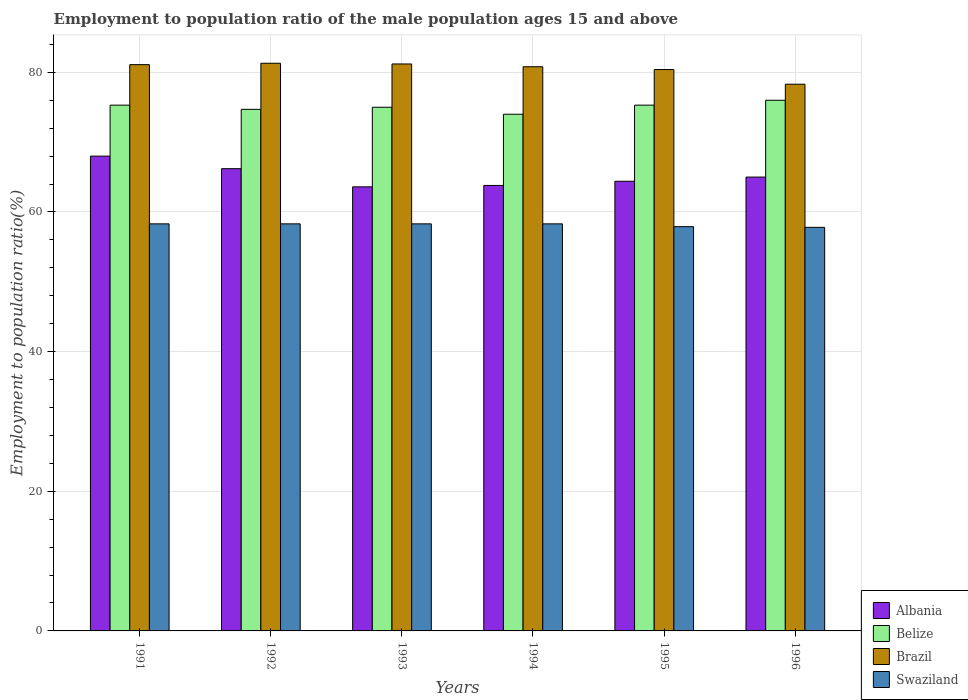How many different coloured bars are there?
Your answer should be very brief. 4. Are the number of bars on each tick of the X-axis equal?
Provide a short and direct response. Yes. How many bars are there on the 5th tick from the right?
Your answer should be very brief. 4. In how many cases, is the number of bars for a given year not equal to the number of legend labels?
Make the answer very short. 0. What is the employment to population ratio in Belize in 1991?
Offer a terse response. 75.3. Across all years, what is the minimum employment to population ratio in Albania?
Provide a short and direct response. 63.6. What is the total employment to population ratio in Swaziland in the graph?
Your answer should be very brief. 348.9. What is the difference between the employment to population ratio in Brazil in 1991 and that in 1993?
Make the answer very short. -0.1. What is the difference between the employment to population ratio in Belize in 1992 and the employment to population ratio in Brazil in 1994?
Your response must be concise. -6.1. What is the average employment to population ratio in Belize per year?
Make the answer very short. 75.05. In the year 1991, what is the difference between the employment to population ratio in Swaziland and employment to population ratio in Albania?
Provide a succinct answer. -9.7. In how many years, is the employment to population ratio in Swaziland greater than 36 %?
Ensure brevity in your answer.  6. What is the ratio of the employment to population ratio in Belize in 1991 to that in 1996?
Give a very brief answer. 0.99. Is the difference between the employment to population ratio in Swaziland in 1991 and 1992 greater than the difference between the employment to population ratio in Albania in 1991 and 1992?
Your answer should be very brief. No. What is the difference between the highest and the second highest employment to population ratio in Swaziland?
Your answer should be compact. 0. What is the difference between the highest and the lowest employment to population ratio in Belize?
Give a very brief answer. 2. Is the sum of the employment to population ratio in Belize in 1991 and 1993 greater than the maximum employment to population ratio in Albania across all years?
Your answer should be compact. Yes. Is it the case that in every year, the sum of the employment to population ratio in Brazil and employment to population ratio in Swaziland is greater than the sum of employment to population ratio in Albania and employment to population ratio in Belize?
Keep it short and to the point. Yes. What does the 1st bar from the left in 1993 represents?
Keep it short and to the point. Albania. What does the 3rd bar from the right in 1992 represents?
Give a very brief answer. Belize. Is it the case that in every year, the sum of the employment to population ratio in Brazil and employment to population ratio in Albania is greater than the employment to population ratio in Belize?
Provide a succinct answer. Yes. Are all the bars in the graph horizontal?
Offer a very short reply. No. How many years are there in the graph?
Make the answer very short. 6. Are the values on the major ticks of Y-axis written in scientific E-notation?
Provide a short and direct response. No. How are the legend labels stacked?
Your answer should be very brief. Vertical. What is the title of the graph?
Offer a terse response. Employment to population ratio of the male population ages 15 and above. Does "Latin America(all income levels)" appear as one of the legend labels in the graph?
Offer a very short reply. No. What is the label or title of the X-axis?
Your answer should be compact. Years. What is the label or title of the Y-axis?
Your response must be concise. Employment to population ratio(%). What is the Employment to population ratio(%) of Albania in 1991?
Offer a very short reply. 68. What is the Employment to population ratio(%) in Belize in 1991?
Your response must be concise. 75.3. What is the Employment to population ratio(%) of Brazil in 1991?
Your response must be concise. 81.1. What is the Employment to population ratio(%) of Swaziland in 1991?
Provide a short and direct response. 58.3. What is the Employment to population ratio(%) of Albania in 1992?
Offer a very short reply. 66.2. What is the Employment to population ratio(%) in Belize in 1992?
Give a very brief answer. 74.7. What is the Employment to population ratio(%) of Brazil in 1992?
Ensure brevity in your answer.  81.3. What is the Employment to population ratio(%) in Swaziland in 1992?
Make the answer very short. 58.3. What is the Employment to population ratio(%) in Albania in 1993?
Your answer should be very brief. 63.6. What is the Employment to population ratio(%) of Belize in 1993?
Provide a short and direct response. 75. What is the Employment to population ratio(%) in Brazil in 1993?
Offer a very short reply. 81.2. What is the Employment to population ratio(%) of Swaziland in 1993?
Your answer should be compact. 58.3. What is the Employment to population ratio(%) in Albania in 1994?
Keep it short and to the point. 63.8. What is the Employment to population ratio(%) of Belize in 1994?
Make the answer very short. 74. What is the Employment to population ratio(%) of Brazil in 1994?
Your answer should be compact. 80.8. What is the Employment to population ratio(%) in Swaziland in 1994?
Your answer should be very brief. 58.3. What is the Employment to population ratio(%) of Albania in 1995?
Your answer should be very brief. 64.4. What is the Employment to population ratio(%) of Belize in 1995?
Keep it short and to the point. 75.3. What is the Employment to population ratio(%) in Brazil in 1995?
Offer a terse response. 80.4. What is the Employment to population ratio(%) of Swaziland in 1995?
Provide a succinct answer. 57.9. What is the Employment to population ratio(%) in Albania in 1996?
Your response must be concise. 65. What is the Employment to population ratio(%) of Brazil in 1996?
Your response must be concise. 78.3. What is the Employment to population ratio(%) of Swaziland in 1996?
Provide a succinct answer. 57.8. Across all years, what is the maximum Employment to population ratio(%) in Brazil?
Your answer should be very brief. 81.3. Across all years, what is the maximum Employment to population ratio(%) of Swaziland?
Offer a terse response. 58.3. Across all years, what is the minimum Employment to population ratio(%) of Albania?
Provide a short and direct response. 63.6. Across all years, what is the minimum Employment to population ratio(%) of Belize?
Ensure brevity in your answer.  74. Across all years, what is the minimum Employment to population ratio(%) of Brazil?
Provide a succinct answer. 78.3. Across all years, what is the minimum Employment to population ratio(%) in Swaziland?
Give a very brief answer. 57.8. What is the total Employment to population ratio(%) of Albania in the graph?
Give a very brief answer. 391. What is the total Employment to population ratio(%) in Belize in the graph?
Your response must be concise. 450.3. What is the total Employment to population ratio(%) in Brazil in the graph?
Offer a terse response. 483.1. What is the total Employment to population ratio(%) of Swaziland in the graph?
Provide a succinct answer. 348.9. What is the difference between the Employment to population ratio(%) in Brazil in 1991 and that in 1992?
Provide a succinct answer. -0.2. What is the difference between the Employment to population ratio(%) of Belize in 1991 and that in 1993?
Ensure brevity in your answer.  0.3. What is the difference between the Employment to population ratio(%) of Albania in 1991 and that in 1994?
Your answer should be compact. 4.2. What is the difference between the Employment to population ratio(%) of Swaziland in 1991 and that in 1994?
Your response must be concise. 0. What is the difference between the Employment to population ratio(%) in Albania in 1991 and that in 1995?
Provide a succinct answer. 3.6. What is the difference between the Employment to population ratio(%) in Belize in 1991 and that in 1996?
Give a very brief answer. -0.7. What is the difference between the Employment to population ratio(%) in Albania in 1992 and that in 1993?
Offer a terse response. 2.6. What is the difference between the Employment to population ratio(%) of Belize in 1992 and that in 1993?
Offer a terse response. -0.3. What is the difference between the Employment to population ratio(%) of Swaziland in 1992 and that in 1993?
Keep it short and to the point. 0. What is the difference between the Employment to population ratio(%) in Belize in 1992 and that in 1994?
Provide a succinct answer. 0.7. What is the difference between the Employment to population ratio(%) of Brazil in 1992 and that in 1995?
Provide a succinct answer. 0.9. What is the difference between the Employment to population ratio(%) in Brazil in 1992 and that in 1996?
Your answer should be compact. 3. What is the difference between the Employment to population ratio(%) of Albania in 1993 and that in 1994?
Provide a short and direct response. -0.2. What is the difference between the Employment to population ratio(%) of Belize in 1993 and that in 1994?
Keep it short and to the point. 1. What is the difference between the Employment to population ratio(%) of Brazil in 1993 and that in 1994?
Provide a succinct answer. 0.4. What is the difference between the Employment to population ratio(%) of Swaziland in 1993 and that in 1994?
Provide a succinct answer. 0. What is the difference between the Employment to population ratio(%) of Albania in 1993 and that in 1995?
Provide a short and direct response. -0.8. What is the difference between the Employment to population ratio(%) in Albania in 1993 and that in 1996?
Your response must be concise. -1.4. What is the difference between the Employment to population ratio(%) in Belize in 1993 and that in 1996?
Your answer should be very brief. -1. What is the difference between the Employment to population ratio(%) in Albania in 1994 and that in 1995?
Your response must be concise. -0.6. What is the difference between the Employment to population ratio(%) in Brazil in 1994 and that in 1995?
Your answer should be compact. 0.4. What is the difference between the Employment to population ratio(%) of Brazil in 1994 and that in 1996?
Offer a very short reply. 2.5. What is the difference between the Employment to population ratio(%) in Albania in 1995 and that in 1996?
Your answer should be compact. -0.6. What is the difference between the Employment to population ratio(%) in Brazil in 1995 and that in 1996?
Provide a short and direct response. 2.1. What is the difference between the Employment to population ratio(%) in Swaziland in 1995 and that in 1996?
Offer a terse response. 0.1. What is the difference between the Employment to population ratio(%) in Brazil in 1991 and the Employment to population ratio(%) in Swaziland in 1992?
Give a very brief answer. 22.8. What is the difference between the Employment to population ratio(%) in Albania in 1991 and the Employment to population ratio(%) in Belize in 1993?
Your answer should be compact. -7. What is the difference between the Employment to population ratio(%) in Belize in 1991 and the Employment to population ratio(%) in Swaziland in 1993?
Your answer should be very brief. 17. What is the difference between the Employment to population ratio(%) of Brazil in 1991 and the Employment to population ratio(%) of Swaziland in 1993?
Make the answer very short. 22.8. What is the difference between the Employment to population ratio(%) of Albania in 1991 and the Employment to population ratio(%) of Belize in 1994?
Your answer should be compact. -6. What is the difference between the Employment to population ratio(%) of Albania in 1991 and the Employment to population ratio(%) of Swaziland in 1994?
Make the answer very short. 9.7. What is the difference between the Employment to population ratio(%) in Brazil in 1991 and the Employment to population ratio(%) in Swaziland in 1994?
Give a very brief answer. 22.8. What is the difference between the Employment to population ratio(%) of Albania in 1991 and the Employment to population ratio(%) of Belize in 1995?
Offer a very short reply. -7.3. What is the difference between the Employment to population ratio(%) of Albania in 1991 and the Employment to population ratio(%) of Brazil in 1995?
Give a very brief answer. -12.4. What is the difference between the Employment to population ratio(%) in Albania in 1991 and the Employment to population ratio(%) in Swaziland in 1995?
Provide a succinct answer. 10.1. What is the difference between the Employment to population ratio(%) of Belize in 1991 and the Employment to population ratio(%) of Swaziland in 1995?
Make the answer very short. 17.4. What is the difference between the Employment to population ratio(%) of Brazil in 1991 and the Employment to population ratio(%) of Swaziland in 1995?
Give a very brief answer. 23.2. What is the difference between the Employment to population ratio(%) in Albania in 1991 and the Employment to population ratio(%) in Belize in 1996?
Provide a short and direct response. -8. What is the difference between the Employment to population ratio(%) in Albania in 1991 and the Employment to population ratio(%) in Swaziland in 1996?
Make the answer very short. 10.2. What is the difference between the Employment to population ratio(%) of Belize in 1991 and the Employment to population ratio(%) of Swaziland in 1996?
Provide a short and direct response. 17.5. What is the difference between the Employment to population ratio(%) of Brazil in 1991 and the Employment to population ratio(%) of Swaziland in 1996?
Your answer should be very brief. 23.3. What is the difference between the Employment to population ratio(%) in Albania in 1992 and the Employment to population ratio(%) in Belize in 1993?
Keep it short and to the point. -8.8. What is the difference between the Employment to population ratio(%) in Albania in 1992 and the Employment to population ratio(%) in Brazil in 1993?
Provide a succinct answer. -15. What is the difference between the Employment to population ratio(%) in Albania in 1992 and the Employment to population ratio(%) in Swaziland in 1993?
Keep it short and to the point. 7.9. What is the difference between the Employment to population ratio(%) in Belize in 1992 and the Employment to population ratio(%) in Brazil in 1993?
Offer a terse response. -6.5. What is the difference between the Employment to population ratio(%) of Albania in 1992 and the Employment to population ratio(%) of Brazil in 1994?
Ensure brevity in your answer.  -14.6. What is the difference between the Employment to population ratio(%) in Belize in 1992 and the Employment to population ratio(%) in Swaziland in 1994?
Your answer should be compact. 16.4. What is the difference between the Employment to population ratio(%) of Albania in 1992 and the Employment to population ratio(%) of Swaziland in 1995?
Give a very brief answer. 8.3. What is the difference between the Employment to population ratio(%) in Belize in 1992 and the Employment to population ratio(%) in Swaziland in 1995?
Make the answer very short. 16.8. What is the difference between the Employment to population ratio(%) in Brazil in 1992 and the Employment to population ratio(%) in Swaziland in 1995?
Provide a short and direct response. 23.4. What is the difference between the Employment to population ratio(%) in Albania in 1992 and the Employment to population ratio(%) in Belize in 1996?
Your response must be concise. -9.8. What is the difference between the Employment to population ratio(%) in Albania in 1992 and the Employment to population ratio(%) in Swaziland in 1996?
Offer a terse response. 8.4. What is the difference between the Employment to population ratio(%) in Albania in 1993 and the Employment to population ratio(%) in Belize in 1994?
Offer a very short reply. -10.4. What is the difference between the Employment to population ratio(%) in Albania in 1993 and the Employment to population ratio(%) in Brazil in 1994?
Offer a terse response. -17.2. What is the difference between the Employment to population ratio(%) in Belize in 1993 and the Employment to population ratio(%) in Brazil in 1994?
Provide a succinct answer. -5.8. What is the difference between the Employment to population ratio(%) of Brazil in 1993 and the Employment to population ratio(%) of Swaziland in 1994?
Keep it short and to the point. 22.9. What is the difference between the Employment to population ratio(%) in Albania in 1993 and the Employment to population ratio(%) in Belize in 1995?
Ensure brevity in your answer.  -11.7. What is the difference between the Employment to population ratio(%) in Albania in 1993 and the Employment to population ratio(%) in Brazil in 1995?
Give a very brief answer. -16.8. What is the difference between the Employment to population ratio(%) in Albania in 1993 and the Employment to population ratio(%) in Swaziland in 1995?
Your response must be concise. 5.7. What is the difference between the Employment to population ratio(%) of Brazil in 1993 and the Employment to population ratio(%) of Swaziland in 1995?
Offer a terse response. 23.3. What is the difference between the Employment to population ratio(%) of Albania in 1993 and the Employment to population ratio(%) of Belize in 1996?
Your answer should be very brief. -12.4. What is the difference between the Employment to population ratio(%) of Albania in 1993 and the Employment to population ratio(%) of Brazil in 1996?
Your answer should be compact. -14.7. What is the difference between the Employment to population ratio(%) in Albania in 1993 and the Employment to population ratio(%) in Swaziland in 1996?
Provide a short and direct response. 5.8. What is the difference between the Employment to population ratio(%) of Belize in 1993 and the Employment to population ratio(%) of Brazil in 1996?
Offer a terse response. -3.3. What is the difference between the Employment to population ratio(%) of Belize in 1993 and the Employment to population ratio(%) of Swaziland in 1996?
Keep it short and to the point. 17.2. What is the difference between the Employment to population ratio(%) in Brazil in 1993 and the Employment to population ratio(%) in Swaziland in 1996?
Give a very brief answer. 23.4. What is the difference between the Employment to population ratio(%) in Albania in 1994 and the Employment to population ratio(%) in Belize in 1995?
Offer a terse response. -11.5. What is the difference between the Employment to population ratio(%) in Albania in 1994 and the Employment to population ratio(%) in Brazil in 1995?
Give a very brief answer. -16.6. What is the difference between the Employment to population ratio(%) in Albania in 1994 and the Employment to population ratio(%) in Swaziland in 1995?
Offer a very short reply. 5.9. What is the difference between the Employment to population ratio(%) of Belize in 1994 and the Employment to population ratio(%) of Brazil in 1995?
Ensure brevity in your answer.  -6.4. What is the difference between the Employment to population ratio(%) in Belize in 1994 and the Employment to population ratio(%) in Swaziland in 1995?
Keep it short and to the point. 16.1. What is the difference between the Employment to population ratio(%) of Brazil in 1994 and the Employment to population ratio(%) of Swaziland in 1995?
Your answer should be very brief. 22.9. What is the difference between the Employment to population ratio(%) of Albania in 1994 and the Employment to population ratio(%) of Belize in 1996?
Offer a very short reply. -12.2. What is the difference between the Employment to population ratio(%) of Albania in 1994 and the Employment to population ratio(%) of Brazil in 1996?
Make the answer very short. -14.5. What is the difference between the Employment to population ratio(%) in Belize in 1994 and the Employment to population ratio(%) in Brazil in 1996?
Your response must be concise. -4.3. What is the difference between the Employment to population ratio(%) of Brazil in 1994 and the Employment to population ratio(%) of Swaziland in 1996?
Keep it short and to the point. 23. What is the difference between the Employment to population ratio(%) of Albania in 1995 and the Employment to population ratio(%) of Belize in 1996?
Keep it short and to the point. -11.6. What is the difference between the Employment to population ratio(%) of Albania in 1995 and the Employment to population ratio(%) of Swaziland in 1996?
Ensure brevity in your answer.  6.6. What is the difference between the Employment to population ratio(%) in Brazil in 1995 and the Employment to population ratio(%) in Swaziland in 1996?
Provide a succinct answer. 22.6. What is the average Employment to population ratio(%) of Albania per year?
Offer a terse response. 65.17. What is the average Employment to population ratio(%) of Belize per year?
Provide a succinct answer. 75.05. What is the average Employment to population ratio(%) in Brazil per year?
Your response must be concise. 80.52. What is the average Employment to population ratio(%) in Swaziland per year?
Make the answer very short. 58.15. In the year 1991, what is the difference between the Employment to population ratio(%) in Albania and Employment to population ratio(%) in Brazil?
Ensure brevity in your answer.  -13.1. In the year 1991, what is the difference between the Employment to population ratio(%) of Albania and Employment to population ratio(%) of Swaziland?
Offer a terse response. 9.7. In the year 1991, what is the difference between the Employment to population ratio(%) of Brazil and Employment to population ratio(%) of Swaziland?
Make the answer very short. 22.8. In the year 1992, what is the difference between the Employment to population ratio(%) of Albania and Employment to population ratio(%) of Brazil?
Provide a succinct answer. -15.1. In the year 1992, what is the difference between the Employment to population ratio(%) of Albania and Employment to population ratio(%) of Swaziland?
Offer a terse response. 7.9. In the year 1993, what is the difference between the Employment to population ratio(%) of Albania and Employment to population ratio(%) of Belize?
Keep it short and to the point. -11.4. In the year 1993, what is the difference between the Employment to population ratio(%) of Albania and Employment to population ratio(%) of Brazil?
Provide a succinct answer. -17.6. In the year 1993, what is the difference between the Employment to population ratio(%) of Belize and Employment to population ratio(%) of Brazil?
Your response must be concise. -6.2. In the year 1993, what is the difference between the Employment to population ratio(%) of Brazil and Employment to population ratio(%) of Swaziland?
Offer a terse response. 22.9. In the year 1996, what is the difference between the Employment to population ratio(%) in Albania and Employment to population ratio(%) in Belize?
Your answer should be very brief. -11. In the year 1996, what is the difference between the Employment to population ratio(%) of Albania and Employment to population ratio(%) of Swaziland?
Your answer should be compact. 7.2. In the year 1996, what is the difference between the Employment to population ratio(%) in Belize and Employment to population ratio(%) in Brazil?
Provide a succinct answer. -2.3. In the year 1996, what is the difference between the Employment to population ratio(%) in Belize and Employment to population ratio(%) in Swaziland?
Offer a very short reply. 18.2. What is the ratio of the Employment to population ratio(%) in Albania in 1991 to that in 1992?
Keep it short and to the point. 1.03. What is the ratio of the Employment to population ratio(%) of Swaziland in 1991 to that in 1992?
Your answer should be compact. 1. What is the ratio of the Employment to population ratio(%) of Albania in 1991 to that in 1993?
Provide a succinct answer. 1.07. What is the ratio of the Employment to population ratio(%) in Belize in 1991 to that in 1993?
Ensure brevity in your answer.  1. What is the ratio of the Employment to population ratio(%) of Albania in 1991 to that in 1994?
Offer a terse response. 1.07. What is the ratio of the Employment to population ratio(%) in Belize in 1991 to that in 1994?
Your response must be concise. 1.02. What is the ratio of the Employment to population ratio(%) of Swaziland in 1991 to that in 1994?
Offer a very short reply. 1. What is the ratio of the Employment to population ratio(%) in Albania in 1991 to that in 1995?
Provide a short and direct response. 1.06. What is the ratio of the Employment to population ratio(%) in Brazil in 1991 to that in 1995?
Offer a very short reply. 1.01. What is the ratio of the Employment to population ratio(%) of Swaziland in 1991 to that in 1995?
Give a very brief answer. 1.01. What is the ratio of the Employment to population ratio(%) in Albania in 1991 to that in 1996?
Provide a succinct answer. 1.05. What is the ratio of the Employment to population ratio(%) of Belize in 1991 to that in 1996?
Keep it short and to the point. 0.99. What is the ratio of the Employment to population ratio(%) in Brazil in 1991 to that in 1996?
Offer a terse response. 1.04. What is the ratio of the Employment to population ratio(%) in Swaziland in 1991 to that in 1996?
Your answer should be very brief. 1.01. What is the ratio of the Employment to population ratio(%) of Albania in 1992 to that in 1993?
Give a very brief answer. 1.04. What is the ratio of the Employment to population ratio(%) of Brazil in 1992 to that in 1993?
Your response must be concise. 1. What is the ratio of the Employment to population ratio(%) in Albania in 1992 to that in 1994?
Keep it short and to the point. 1.04. What is the ratio of the Employment to population ratio(%) of Belize in 1992 to that in 1994?
Your response must be concise. 1.01. What is the ratio of the Employment to population ratio(%) of Albania in 1992 to that in 1995?
Your response must be concise. 1.03. What is the ratio of the Employment to population ratio(%) in Belize in 1992 to that in 1995?
Offer a very short reply. 0.99. What is the ratio of the Employment to population ratio(%) of Brazil in 1992 to that in 1995?
Your answer should be very brief. 1.01. What is the ratio of the Employment to population ratio(%) in Swaziland in 1992 to that in 1995?
Your answer should be very brief. 1.01. What is the ratio of the Employment to population ratio(%) of Albania in 1992 to that in 1996?
Make the answer very short. 1.02. What is the ratio of the Employment to population ratio(%) in Belize in 1992 to that in 1996?
Make the answer very short. 0.98. What is the ratio of the Employment to population ratio(%) of Brazil in 1992 to that in 1996?
Make the answer very short. 1.04. What is the ratio of the Employment to population ratio(%) in Swaziland in 1992 to that in 1996?
Make the answer very short. 1.01. What is the ratio of the Employment to population ratio(%) of Albania in 1993 to that in 1994?
Give a very brief answer. 1. What is the ratio of the Employment to population ratio(%) in Belize in 1993 to that in 1994?
Provide a short and direct response. 1.01. What is the ratio of the Employment to population ratio(%) of Brazil in 1993 to that in 1994?
Provide a short and direct response. 1. What is the ratio of the Employment to population ratio(%) in Albania in 1993 to that in 1995?
Your answer should be compact. 0.99. What is the ratio of the Employment to population ratio(%) of Belize in 1993 to that in 1995?
Provide a short and direct response. 1. What is the ratio of the Employment to population ratio(%) in Brazil in 1993 to that in 1995?
Give a very brief answer. 1.01. What is the ratio of the Employment to population ratio(%) of Albania in 1993 to that in 1996?
Your answer should be very brief. 0.98. What is the ratio of the Employment to population ratio(%) of Brazil in 1993 to that in 1996?
Offer a very short reply. 1.04. What is the ratio of the Employment to population ratio(%) in Swaziland in 1993 to that in 1996?
Your answer should be compact. 1.01. What is the ratio of the Employment to population ratio(%) of Belize in 1994 to that in 1995?
Provide a short and direct response. 0.98. What is the ratio of the Employment to population ratio(%) of Brazil in 1994 to that in 1995?
Your answer should be very brief. 1. What is the ratio of the Employment to population ratio(%) of Albania in 1994 to that in 1996?
Offer a very short reply. 0.98. What is the ratio of the Employment to population ratio(%) in Belize in 1994 to that in 1996?
Your answer should be very brief. 0.97. What is the ratio of the Employment to population ratio(%) of Brazil in 1994 to that in 1996?
Your answer should be compact. 1.03. What is the ratio of the Employment to population ratio(%) in Swaziland in 1994 to that in 1996?
Your response must be concise. 1.01. What is the ratio of the Employment to population ratio(%) in Brazil in 1995 to that in 1996?
Offer a terse response. 1.03. What is the ratio of the Employment to population ratio(%) in Swaziland in 1995 to that in 1996?
Keep it short and to the point. 1. What is the difference between the highest and the second highest Employment to population ratio(%) in Albania?
Provide a short and direct response. 1.8. What is the difference between the highest and the second highest Employment to population ratio(%) of Belize?
Provide a succinct answer. 0.7. What is the difference between the highest and the second highest Employment to population ratio(%) in Brazil?
Your answer should be compact. 0.1. What is the difference between the highest and the lowest Employment to population ratio(%) in Albania?
Provide a succinct answer. 4.4. What is the difference between the highest and the lowest Employment to population ratio(%) of Brazil?
Keep it short and to the point. 3. What is the difference between the highest and the lowest Employment to population ratio(%) of Swaziland?
Offer a terse response. 0.5. 